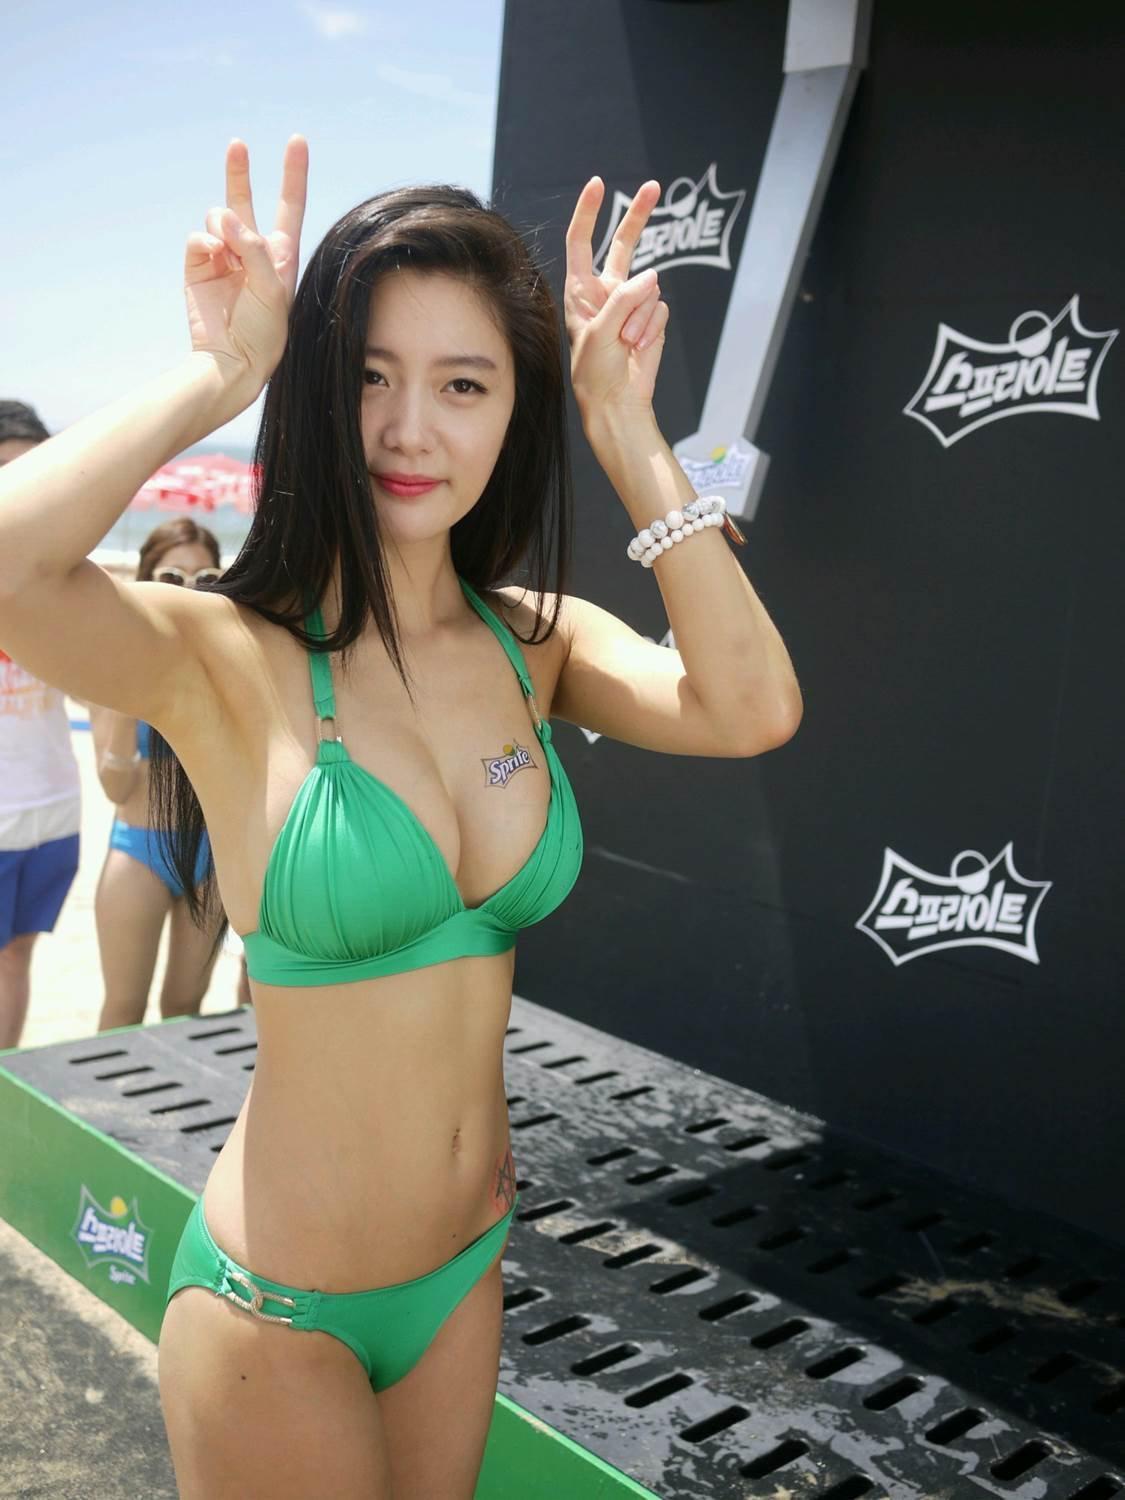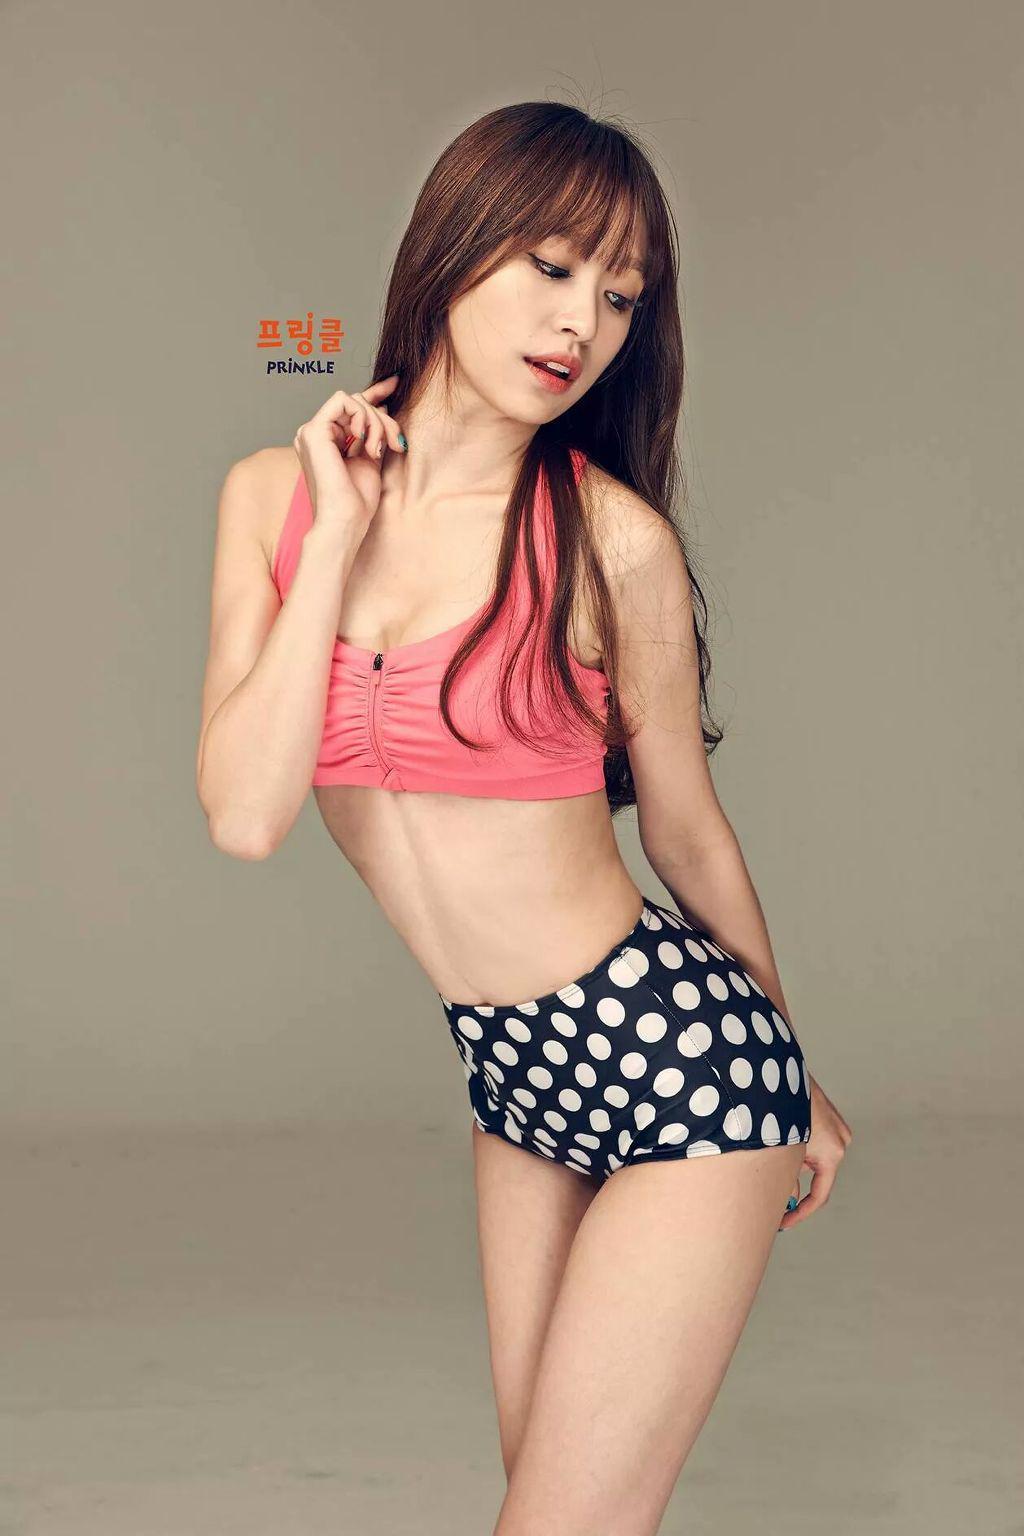The first image is the image on the left, the second image is the image on the right. Analyze the images presented: Is the assertion "The bikini-clad girls are wearing high heels in the pool." valid? Answer yes or no. No. The first image is the image on the left, the second image is the image on the right. Assess this claim about the two images: "The left and right image contains the same number of women in bikinis.". Correct or not? Answer yes or no. Yes. 